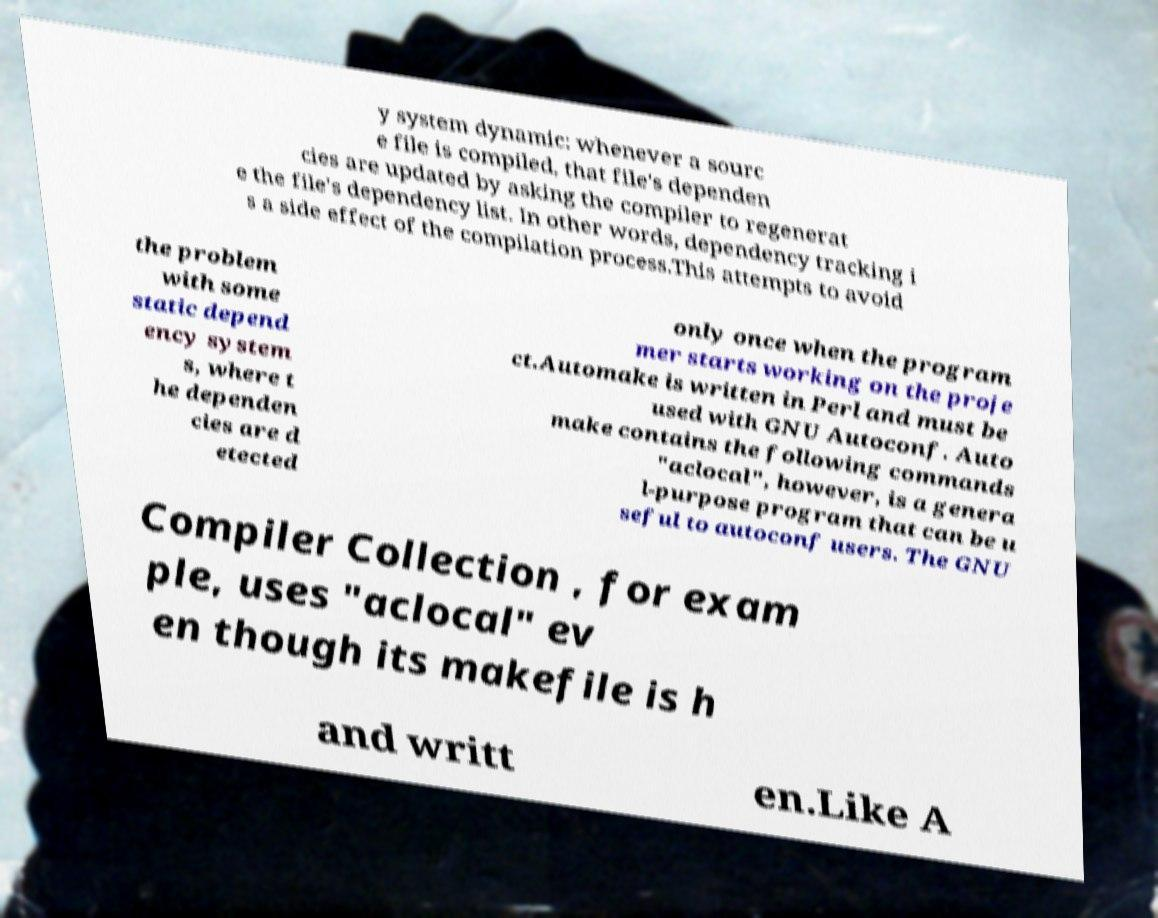I need the written content from this picture converted into text. Can you do that? y system dynamic: whenever a sourc e file is compiled, that file's dependen cies are updated by asking the compiler to regenerat e the file's dependency list. In other words, dependency tracking i s a side effect of the compilation process.This attempts to avoid the problem with some static depend ency system s, where t he dependen cies are d etected only once when the program mer starts working on the proje ct.Automake is written in Perl and must be used with GNU Autoconf. Auto make contains the following commands "aclocal", however, is a genera l-purpose program that can be u seful to autoconf users. The GNU Compiler Collection , for exam ple, uses "aclocal" ev en though its makefile is h and writt en.Like A 